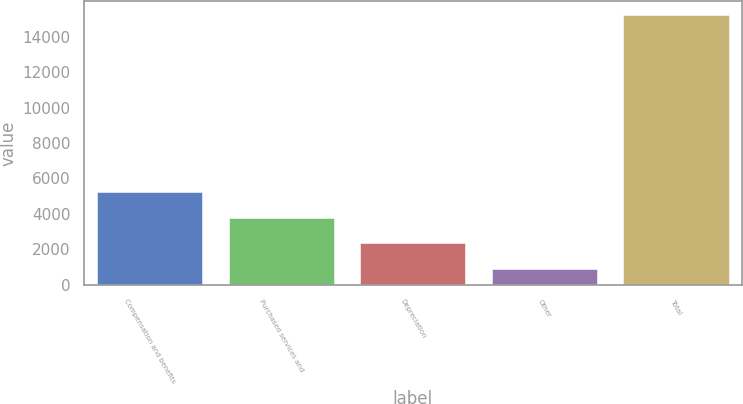Convert chart to OTSL. <chart><loc_0><loc_0><loc_500><loc_500><bar_chart><fcel>Compensation and benefits<fcel>Purchased services and<fcel>Depreciation<fcel>Other<fcel>Total<nl><fcel>5217.3<fcel>3786.2<fcel>2355.1<fcel>924<fcel>15235<nl></chart> 